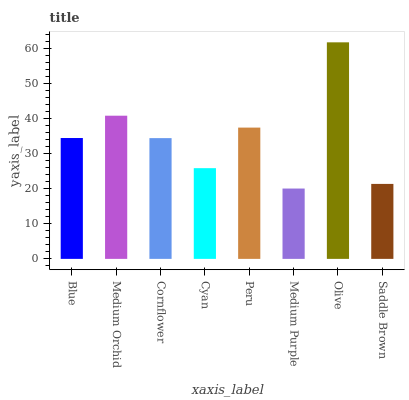Is Medium Purple the minimum?
Answer yes or no. Yes. Is Olive the maximum?
Answer yes or no. Yes. Is Medium Orchid the minimum?
Answer yes or no. No. Is Medium Orchid the maximum?
Answer yes or no. No. Is Medium Orchid greater than Blue?
Answer yes or no. Yes. Is Blue less than Medium Orchid?
Answer yes or no. Yes. Is Blue greater than Medium Orchid?
Answer yes or no. No. Is Medium Orchid less than Blue?
Answer yes or no. No. Is Blue the high median?
Answer yes or no. Yes. Is Cornflower the low median?
Answer yes or no. Yes. Is Saddle Brown the high median?
Answer yes or no. No. Is Blue the low median?
Answer yes or no. No. 